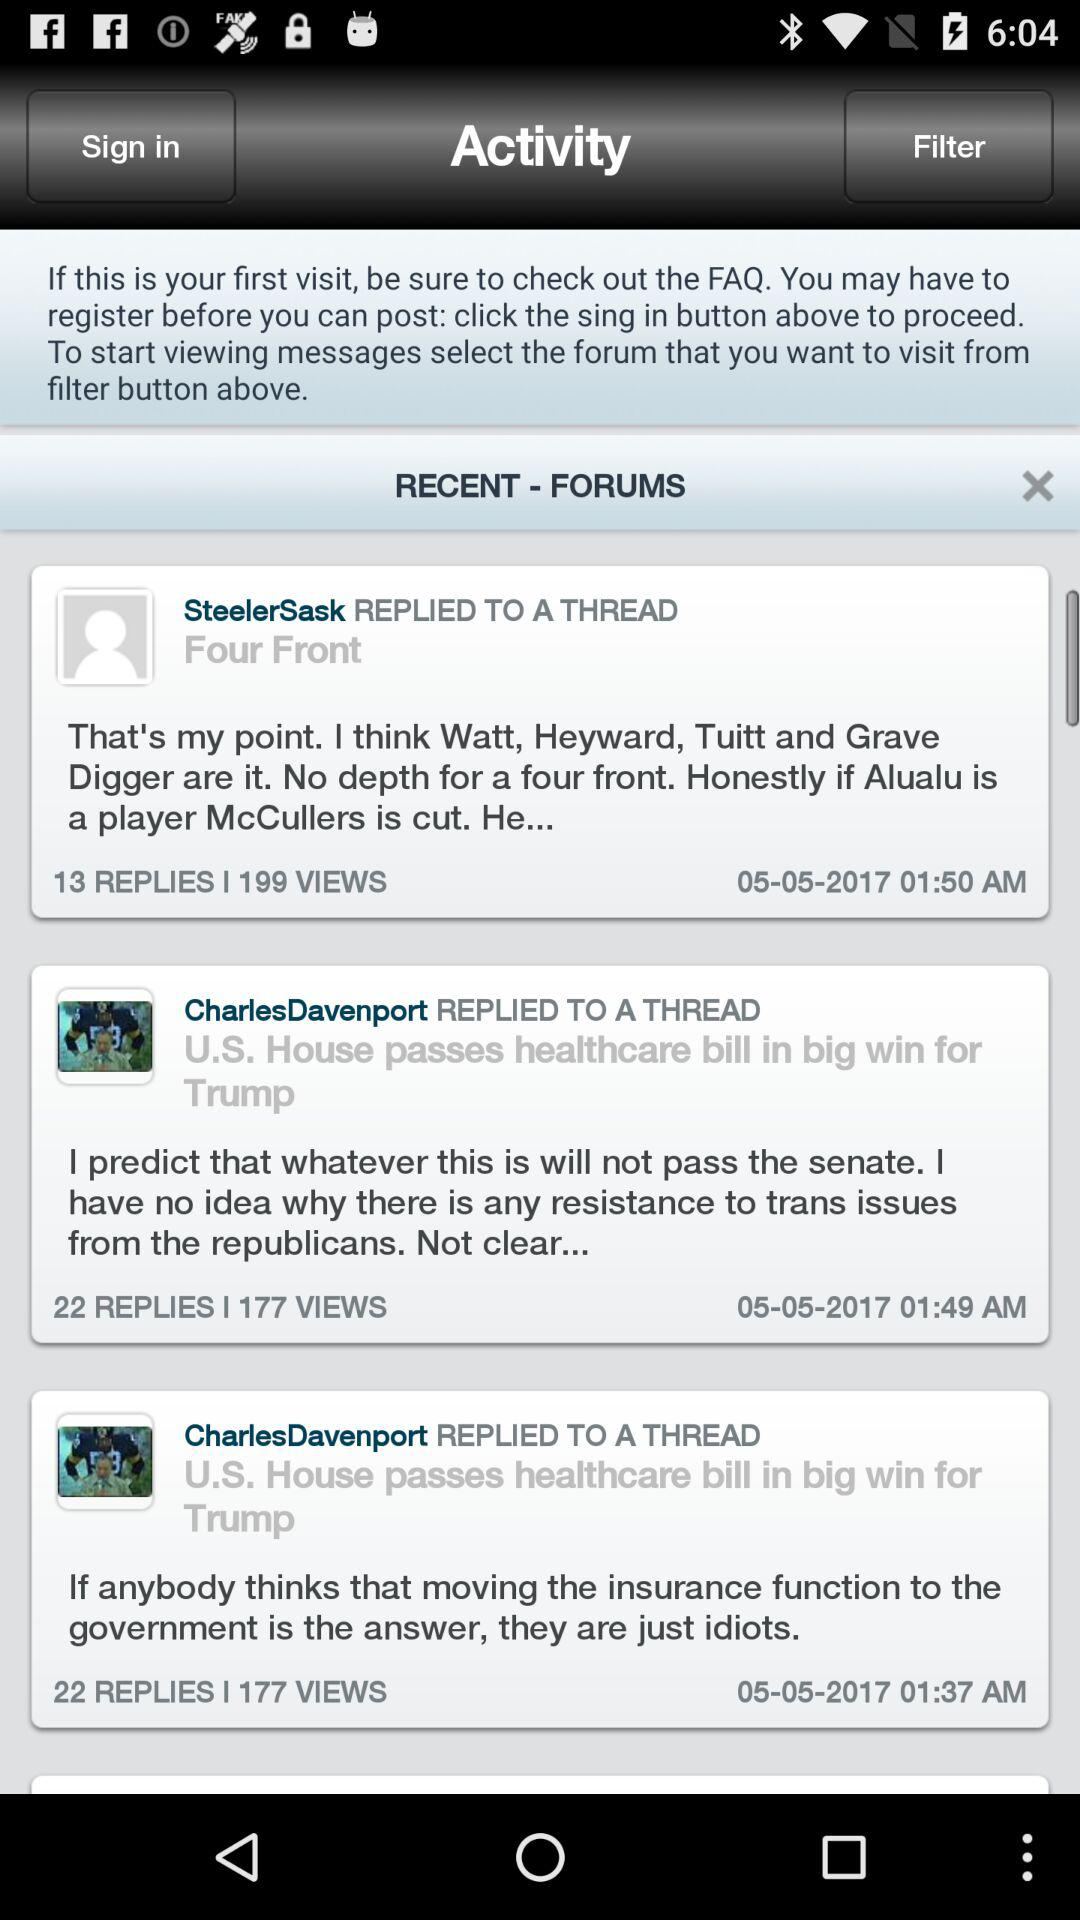How many replies does the first message have?
Answer the question using a single word or phrase. 13 